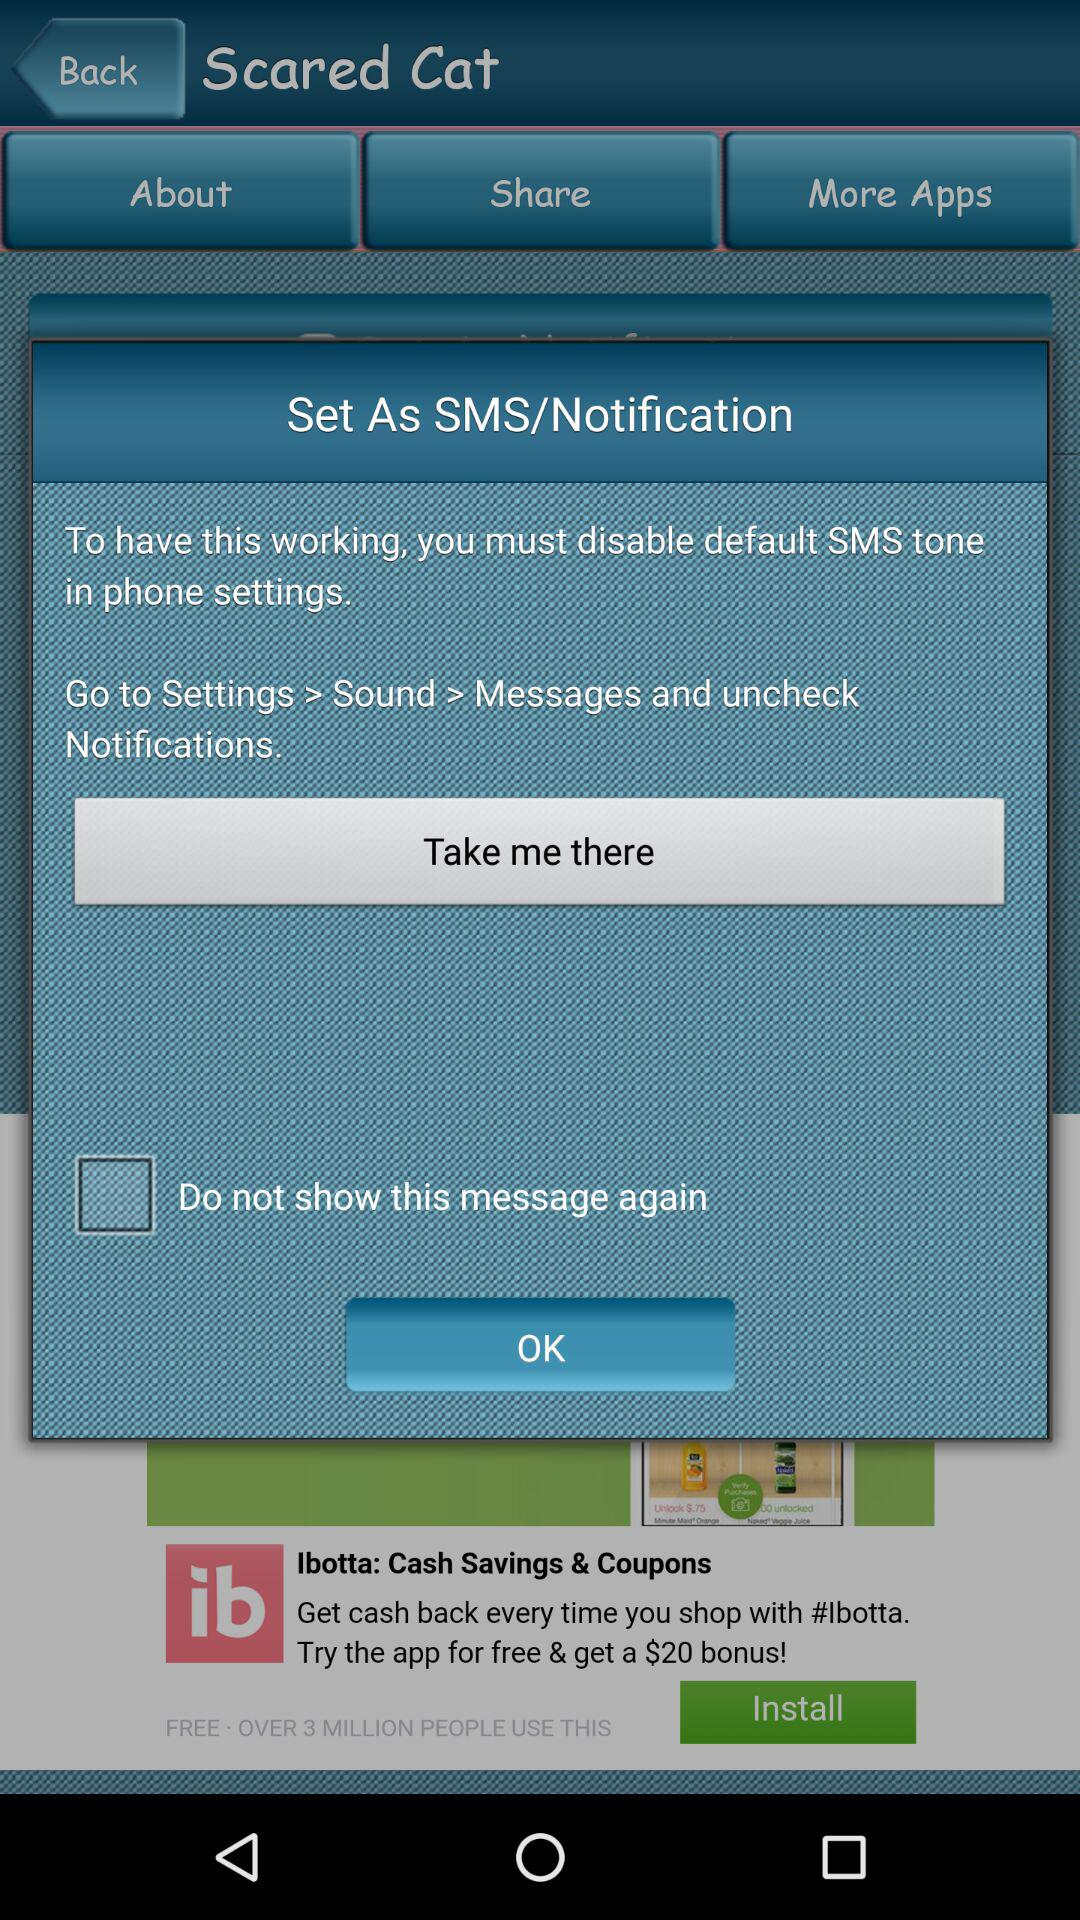How to unlock notifications?
When the provided information is insufficient, respond with <no answer>. <no answer> 